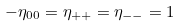Convert formula to latex. <formula><loc_0><loc_0><loc_500><loc_500>- \eta _ { 0 0 } = \eta _ { + + } = \eta _ { - - } = 1</formula> 